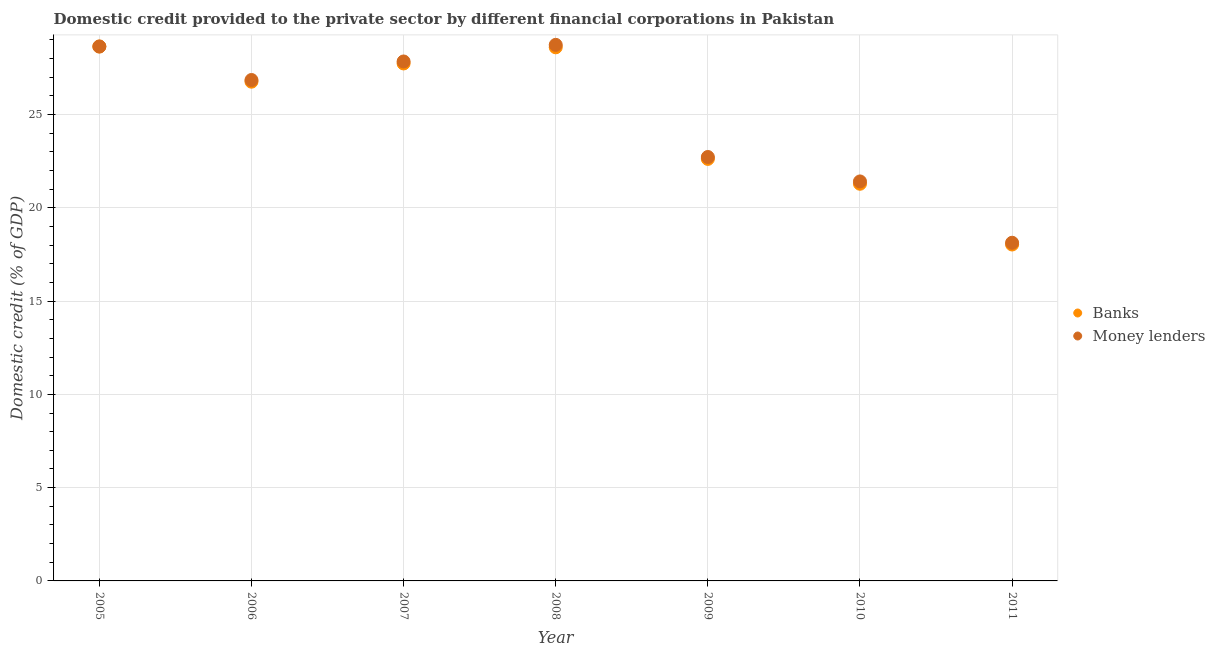How many different coloured dotlines are there?
Make the answer very short. 2. What is the domestic credit provided by banks in 2011?
Provide a short and direct response. 18.03. Across all years, what is the maximum domestic credit provided by money lenders?
Give a very brief answer. 28.73. Across all years, what is the minimum domestic credit provided by money lenders?
Your response must be concise. 18.13. What is the total domestic credit provided by banks in the graph?
Your response must be concise. 173.69. What is the difference between the domestic credit provided by banks in 2006 and that in 2009?
Provide a succinct answer. 4.14. What is the difference between the domestic credit provided by banks in 2008 and the domestic credit provided by money lenders in 2009?
Provide a short and direct response. 5.88. What is the average domestic credit provided by money lenders per year?
Your answer should be very brief. 24.9. In the year 2007, what is the difference between the domestic credit provided by money lenders and domestic credit provided by banks?
Your answer should be compact. 0.11. In how many years, is the domestic credit provided by banks greater than 11 %?
Provide a succinct answer. 7. What is the ratio of the domestic credit provided by banks in 2005 to that in 2010?
Offer a terse response. 1.35. Is the difference between the domestic credit provided by banks in 2009 and 2010 greater than the difference between the domestic credit provided by money lenders in 2009 and 2010?
Give a very brief answer. Yes. What is the difference between the highest and the second highest domestic credit provided by money lenders?
Offer a very short reply. 0.09. What is the difference between the highest and the lowest domestic credit provided by banks?
Make the answer very short. 10.61. Does the domestic credit provided by banks monotonically increase over the years?
Your answer should be very brief. No. Is the domestic credit provided by money lenders strictly less than the domestic credit provided by banks over the years?
Offer a terse response. No. How many dotlines are there?
Offer a terse response. 2. What is the difference between two consecutive major ticks on the Y-axis?
Ensure brevity in your answer.  5. Are the values on the major ticks of Y-axis written in scientific E-notation?
Your answer should be compact. No. Where does the legend appear in the graph?
Keep it short and to the point. Center right. How are the legend labels stacked?
Provide a short and direct response. Vertical. What is the title of the graph?
Your response must be concise. Domestic credit provided to the private sector by different financial corporations in Pakistan. Does "Secondary Education" appear as one of the legend labels in the graph?
Your response must be concise. No. What is the label or title of the X-axis?
Your answer should be very brief. Year. What is the label or title of the Y-axis?
Make the answer very short. Domestic credit (% of GDP). What is the Domestic credit (% of GDP) in Banks in 2005?
Your answer should be very brief. 28.65. What is the Domestic credit (% of GDP) in Money lenders in 2005?
Your response must be concise. 28.65. What is the Domestic credit (% of GDP) in Banks in 2006?
Offer a very short reply. 26.76. What is the Domestic credit (% of GDP) in Money lenders in 2006?
Ensure brevity in your answer.  26.85. What is the Domestic credit (% of GDP) of Banks in 2007?
Make the answer very short. 27.74. What is the Domestic credit (% of GDP) in Money lenders in 2007?
Your response must be concise. 27.84. What is the Domestic credit (% of GDP) of Banks in 2008?
Ensure brevity in your answer.  28.6. What is the Domestic credit (% of GDP) of Money lenders in 2008?
Provide a short and direct response. 28.73. What is the Domestic credit (% of GDP) in Banks in 2009?
Provide a succinct answer. 22.62. What is the Domestic credit (% of GDP) in Money lenders in 2009?
Your answer should be very brief. 22.72. What is the Domestic credit (% of GDP) in Banks in 2010?
Give a very brief answer. 21.29. What is the Domestic credit (% of GDP) in Money lenders in 2010?
Make the answer very short. 21.41. What is the Domestic credit (% of GDP) in Banks in 2011?
Make the answer very short. 18.03. What is the Domestic credit (% of GDP) of Money lenders in 2011?
Your answer should be very brief. 18.13. Across all years, what is the maximum Domestic credit (% of GDP) in Banks?
Provide a short and direct response. 28.65. Across all years, what is the maximum Domestic credit (% of GDP) in Money lenders?
Offer a terse response. 28.73. Across all years, what is the minimum Domestic credit (% of GDP) in Banks?
Your answer should be very brief. 18.03. Across all years, what is the minimum Domestic credit (% of GDP) in Money lenders?
Make the answer very short. 18.13. What is the total Domestic credit (% of GDP) in Banks in the graph?
Provide a short and direct response. 173.69. What is the total Domestic credit (% of GDP) in Money lenders in the graph?
Your response must be concise. 174.33. What is the difference between the Domestic credit (% of GDP) of Banks in 2005 and that in 2006?
Keep it short and to the point. 1.89. What is the difference between the Domestic credit (% of GDP) in Money lenders in 2005 and that in 2006?
Your answer should be compact. 1.8. What is the difference between the Domestic credit (% of GDP) in Banks in 2005 and that in 2007?
Make the answer very short. 0.91. What is the difference between the Domestic credit (% of GDP) of Money lenders in 2005 and that in 2007?
Provide a short and direct response. 0.8. What is the difference between the Domestic credit (% of GDP) in Banks in 2005 and that in 2008?
Give a very brief answer. 0.04. What is the difference between the Domestic credit (% of GDP) of Money lenders in 2005 and that in 2008?
Your answer should be very brief. -0.09. What is the difference between the Domestic credit (% of GDP) in Banks in 2005 and that in 2009?
Your response must be concise. 6.02. What is the difference between the Domestic credit (% of GDP) in Money lenders in 2005 and that in 2009?
Ensure brevity in your answer.  5.92. What is the difference between the Domestic credit (% of GDP) of Banks in 2005 and that in 2010?
Your response must be concise. 7.36. What is the difference between the Domestic credit (% of GDP) in Money lenders in 2005 and that in 2010?
Give a very brief answer. 7.23. What is the difference between the Domestic credit (% of GDP) in Banks in 2005 and that in 2011?
Provide a short and direct response. 10.61. What is the difference between the Domestic credit (% of GDP) of Money lenders in 2005 and that in 2011?
Offer a terse response. 10.52. What is the difference between the Domestic credit (% of GDP) of Banks in 2006 and that in 2007?
Provide a short and direct response. -0.98. What is the difference between the Domestic credit (% of GDP) in Money lenders in 2006 and that in 2007?
Offer a terse response. -0.99. What is the difference between the Domestic credit (% of GDP) of Banks in 2006 and that in 2008?
Give a very brief answer. -1.84. What is the difference between the Domestic credit (% of GDP) of Money lenders in 2006 and that in 2008?
Your answer should be compact. -1.88. What is the difference between the Domestic credit (% of GDP) in Banks in 2006 and that in 2009?
Your answer should be very brief. 4.14. What is the difference between the Domestic credit (% of GDP) of Money lenders in 2006 and that in 2009?
Your answer should be very brief. 4.13. What is the difference between the Domestic credit (% of GDP) of Banks in 2006 and that in 2010?
Give a very brief answer. 5.47. What is the difference between the Domestic credit (% of GDP) of Money lenders in 2006 and that in 2010?
Your response must be concise. 5.44. What is the difference between the Domestic credit (% of GDP) of Banks in 2006 and that in 2011?
Offer a terse response. 8.73. What is the difference between the Domestic credit (% of GDP) in Money lenders in 2006 and that in 2011?
Your answer should be compact. 8.72. What is the difference between the Domestic credit (% of GDP) of Banks in 2007 and that in 2008?
Your answer should be compact. -0.87. What is the difference between the Domestic credit (% of GDP) in Money lenders in 2007 and that in 2008?
Your answer should be compact. -0.89. What is the difference between the Domestic credit (% of GDP) of Banks in 2007 and that in 2009?
Your answer should be very brief. 5.12. What is the difference between the Domestic credit (% of GDP) of Money lenders in 2007 and that in 2009?
Provide a short and direct response. 5.12. What is the difference between the Domestic credit (% of GDP) in Banks in 2007 and that in 2010?
Give a very brief answer. 6.45. What is the difference between the Domestic credit (% of GDP) in Money lenders in 2007 and that in 2010?
Offer a terse response. 6.43. What is the difference between the Domestic credit (% of GDP) in Banks in 2007 and that in 2011?
Make the answer very short. 9.7. What is the difference between the Domestic credit (% of GDP) of Money lenders in 2007 and that in 2011?
Offer a very short reply. 9.72. What is the difference between the Domestic credit (% of GDP) in Banks in 2008 and that in 2009?
Provide a succinct answer. 5.98. What is the difference between the Domestic credit (% of GDP) in Money lenders in 2008 and that in 2009?
Provide a short and direct response. 6.01. What is the difference between the Domestic credit (% of GDP) in Banks in 2008 and that in 2010?
Keep it short and to the point. 7.31. What is the difference between the Domestic credit (% of GDP) in Money lenders in 2008 and that in 2010?
Make the answer very short. 7.32. What is the difference between the Domestic credit (% of GDP) in Banks in 2008 and that in 2011?
Give a very brief answer. 10.57. What is the difference between the Domestic credit (% of GDP) of Money lenders in 2008 and that in 2011?
Offer a very short reply. 10.61. What is the difference between the Domestic credit (% of GDP) of Banks in 2009 and that in 2010?
Offer a very short reply. 1.33. What is the difference between the Domestic credit (% of GDP) of Money lenders in 2009 and that in 2010?
Provide a succinct answer. 1.31. What is the difference between the Domestic credit (% of GDP) in Banks in 2009 and that in 2011?
Your answer should be very brief. 4.59. What is the difference between the Domestic credit (% of GDP) in Money lenders in 2009 and that in 2011?
Provide a short and direct response. 4.6. What is the difference between the Domestic credit (% of GDP) of Banks in 2010 and that in 2011?
Provide a short and direct response. 3.26. What is the difference between the Domestic credit (% of GDP) in Money lenders in 2010 and that in 2011?
Give a very brief answer. 3.29. What is the difference between the Domestic credit (% of GDP) of Banks in 2005 and the Domestic credit (% of GDP) of Money lenders in 2006?
Keep it short and to the point. 1.8. What is the difference between the Domestic credit (% of GDP) in Banks in 2005 and the Domestic credit (% of GDP) in Money lenders in 2007?
Keep it short and to the point. 0.8. What is the difference between the Domestic credit (% of GDP) in Banks in 2005 and the Domestic credit (% of GDP) in Money lenders in 2008?
Your answer should be very brief. -0.09. What is the difference between the Domestic credit (% of GDP) in Banks in 2005 and the Domestic credit (% of GDP) in Money lenders in 2009?
Ensure brevity in your answer.  5.92. What is the difference between the Domestic credit (% of GDP) in Banks in 2005 and the Domestic credit (% of GDP) in Money lenders in 2010?
Make the answer very short. 7.23. What is the difference between the Domestic credit (% of GDP) of Banks in 2005 and the Domestic credit (% of GDP) of Money lenders in 2011?
Offer a very short reply. 10.52. What is the difference between the Domestic credit (% of GDP) in Banks in 2006 and the Domestic credit (% of GDP) in Money lenders in 2007?
Give a very brief answer. -1.08. What is the difference between the Domestic credit (% of GDP) in Banks in 2006 and the Domestic credit (% of GDP) in Money lenders in 2008?
Offer a terse response. -1.97. What is the difference between the Domestic credit (% of GDP) in Banks in 2006 and the Domestic credit (% of GDP) in Money lenders in 2009?
Make the answer very short. 4.04. What is the difference between the Domestic credit (% of GDP) of Banks in 2006 and the Domestic credit (% of GDP) of Money lenders in 2010?
Keep it short and to the point. 5.35. What is the difference between the Domestic credit (% of GDP) of Banks in 2006 and the Domestic credit (% of GDP) of Money lenders in 2011?
Provide a short and direct response. 8.63. What is the difference between the Domestic credit (% of GDP) of Banks in 2007 and the Domestic credit (% of GDP) of Money lenders in 2008?
Offer a very short reply. -1. What is the difference between the Domestic credit (% of GDP) in Banks in 2007 and the Domestic credit (% of GDP) in Money lenders in 2009?
Keep it short and to the point. 5.01. What is the difference between the Domestic credit (% of GDP) of Banks in 2007 and the Domestic credit (% of GDP) of Money lenders in 2010?
Offer a very short reply. 6.32. What is the difference between the Domestic credit (% of GDP) of Banks in 2007 and the Domestic credit (% of GDP) of Money lenders in 2011?
Give a very brief answer. 9.61. What is the difference between the Domestic credit (% of GDP) in Banks in 2008 and the Domestic credit (% of GDP) in Money lenders in 2009?
Provide a succinct answer. 5.88. What is the difference between the Domestic credit (% of GDP) of Banks in 2008 and the Domestic credit (% of GDP) of Money lenders in 2010?
Provide a short and direct response. 7.19. What is the difference between the Domestic credit (% of GDP) in Banks in 2008 and the Domestic credit (% of GDP) in Money lenders in 2011?
Offer a terse response. 10.48. What is the difference between the Domestic credit (% of GDP) in Banks in 2009 and the Domestic credit (% of GDP) in Money lenders in 2010?
Your answer should be very brief. 1.21. What is the difference between the Domestic credit (% of GDP) of Banks in 2009 and the Domestic credit (% of GDP) of Money lenders in 2011?
Give a very brief answer. 4.49. What is the difference between the Domestic credit (% of GDP) of Banks in 2010 and the Domestic credit (% of GDP) of Money lenders in 2011?
Ensure brevity in your answer.  3.16. What is the average Domestic credit (% of GDP) of Banks per year?
Keep it short and to the point. 24.81. What is the average Domestic credit (% of GDP) of Money lenders per year?
Give a very brief answer. 24.9. In the year 2006, what is the difference between the Domestic credit (% of GDP) of Banks and Domestic credit (% of GDP) of Money lenders?
Your response must be concise. -0.09. In the year 2007, what is the difference between the Domestic credit (% of GDP) in Banks and Domestic credit (% of GDP) in Money lenders?
Ensure brevity in your answer.  -0.11. In the year 2008, what is the difference between the Domestic credit (% of GDP) in Banks and Domestic credit (% of GDP) in Money lenders?
Keep it short and to the point. -0.13. In the year 2009, what is the difference between the Domestic credit (% of GDP) in Banks and Domestic credit (% of GDP) in Money lenders?
Offer a terse response. -0.1. In the year 2010, what is the difference between the Domestic credit (% of GDP) in Banks and Domestic credit (% of GDP) in Money lenders?
Offer a very short reply. -0.12. In the year 2011, what is the difference between the Domestic credit (% of GDP) of Banks and Domestic credit (% of GDP) of Money lenders?
Your response must be concise. -0.09. What is the ratio of the Domestic credit (% of GDP) of Banks in 2005 to that in 2006?
Ensure brevity in your answer.  1.07. What is the ratio of the Domestic credit (% of GDP) in Money lenders in 2005 to that in 2006?
Provide a short and direct response. 1.07. What is the ratio of the Domestic credit (% of GDP) in Banks in 2005 to that in 2007?
Provide a short and direct response. 1.03. What is the ratio of the Domestic credit (% of GDP) of Money lenders in 2005 to that in 2007?
Keep it short and to the point. 1.03. What is the ratio of the Domestic credit (% of GDP) in Money lenders in 2005 to that in 2008?
Give a very brief answer. 1. What is the ratio of the Domestic credit (% of GDP) in Banks in 2005 to that in 2009?
Offer a very short reply. 1.27. What is the ratio of the Domestic credit (% of GDP) in Money lenders in 2005 to that in 2009?
Provide a succinct answer. 1.26. What is the ratio of the Domestic credit (% of GDP) of Banks in 2005 to that in 2010?
Keep it short and to the point. 1.35. What is the ratio of the Domestic credit (% of GDP) in Money lenders in 2005 to that in 2010?
Make the answer very short. 1.34. What is the ratio of the Domestic credit (% of GDP) in Banks in 2005 to that in 2011?
Provide a short and direct response. 1.59. What is the ratio of the Domestic credit (% of GDP) of Money lenders in 2005 to that in 2011?
Provide a short and direct response. 1.58. What is the ratio of the Domestic credit (% of GDP) of Banks in 2006 to that in 2007?
Keep it short and to the point. 0.96. What is the ratio of the Domestic credit (% of GDP) of Banks in 2006 to that in 2008?
Your response must be concise. 0.94. What is the ratio of the Domestic credit (% of GDP) of Money lenders in 2006 to that in 2008?
Provide a succinct answer. 0.93. What is the ratio of the Domestic credit (% of GDP) of Banks in 2006 to that in 2009?
Keep it short and to the point. 1.18. What is the ratio of the Domestic credit (% of GDP) in Money lenders in 2006 to that in 2009?
Keep it short and to the point. 1.18. What is the ratio of the Domestic credit (% of GDP) in Banks in 2006 to that in 2010?
Your response must be concise. 1.26. What is the ratio of the Domestic credit (% of GDP) of Money lenders in 2006 to that in 2010?
Give a very brief answer. 1.25. What is the ratio of the Domestic credit (% of GDP) of Banks in 2006 to that in 2011?
Your answer should be compact. 1.48. What is the ratio of the Domestic credit (% of GDP) in Money lenders in 2006 to that in 2011?
Make the answer very short. 1.48. What is the ratio of the Domestic credit (% of GDP) of Banks in 2007 to that in 2008?
Offer a very short reply. 0.97. What is the ratio of the Domestic credit (% of GDP) of Banks in 2007 to that in 2009?
Give a very brief answer. 1.23. What is the ratio of the Domestic credit (% of GDP) of Money lenders in 2007 to that in 2009?
Keep it short and to the point. 1.23. What is the ratio of the Domestic credit (% of GDP) of Banks in 2007 to that in 2010?
Offer a very short reply. 1.3. What is the ratio of the Domestic credit (% of GDP) in Money lenders in 2007 to that in 2010?
Your answer should be compact. 1.3. What is the ratio of the Domestic credit (% of GDP) in Banks in 2007 to that in 2011?
Provide a succinct answer. 1.54. What is the ratio of the Domestic credit (% of GDP) in Money lenders in 2007 to that in 2011?
Make the answer very short. 1.54. What is the ratio of the Domestic credit (% of GDP) in Banks in 2008 to that in 2009?
Your answer should be very brief. 1.26. What is the ratio of the Domestic credit (% of GDP) of Money lenders in 2008 to that in 2009?
Your answer should be very brief. 1.26. What is the ratio of the Domestic credit (% of GDP) of Banks in 2008 to that in 2010?
Your answer should be compact. 1.34. What is the ratio of the Domestic credit (% of GDP) in Money lenders in 2008 to that in 2010?
Provide a succinct answer. 1.34. What is the ratio of the Domestic credit (% of GDP) in Banks in 2008 to that in 2011?
Ensure brevity in your answer.  1.59. What is the ratio of the Domestic credit (% of GDP) of Money lenders in 2008 to that in 2011?
Provide a short and direct response. 1.59. What is the ratio of the Domestic credit (% of GDP) of Banks in 2009 to that in 2010?
Keep it short and to the point. 1.06. What is the ratio of the Domestic credit (% of GDP) of Money lenders in 2009 to that in 2010?
Make the answer very short. 1.06. What is the ratio of the Domestic credit (% of GDP) of Banks in 2009 to that in 2011?
Provide a short and direct response. 1.25. What is the ratio of the Domestic credit (% of GDP) of Money lenders in 2009 to that in 2011?
Give a very brief answer. 1.25. What is the ratio of the Domestic credit (% of GDP) of Banks in 2010 to that in 2011?
Offer a terse response. 1.18. What is the ratio of the Domestic credit (% of GDP) of Money lenders in 2010 to that in 2011?
Your response must be concise. 1.18. What is the difference between the highest and the second highest Domestic credit (% of GDP) of Banks?
Offer a very short reply. 0.04. What is the difference between the highest and the second highest Domestic credit (% of GDP) of Money lenders?
Make the answer very short. 0.09. What is the difference between the highest and the lowest Domestic credit (% of GDP) of Banks?
Your answer should be very brief. 10.61. What is the difference between the highest and the lowest Domestic credit (% of GDP) in Money lenders?
Your answer should be compact. 10.61. 